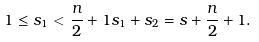Convert formula to latex. <formula><loc_0><loc_0><loc_500><loc_500>1 \leq s _ { 1 } < \frac { n } { 2 } + 1 s _ { 1 } + s _ { 2 } = s + \frac { n } { 2 } + 1 .</formula> 